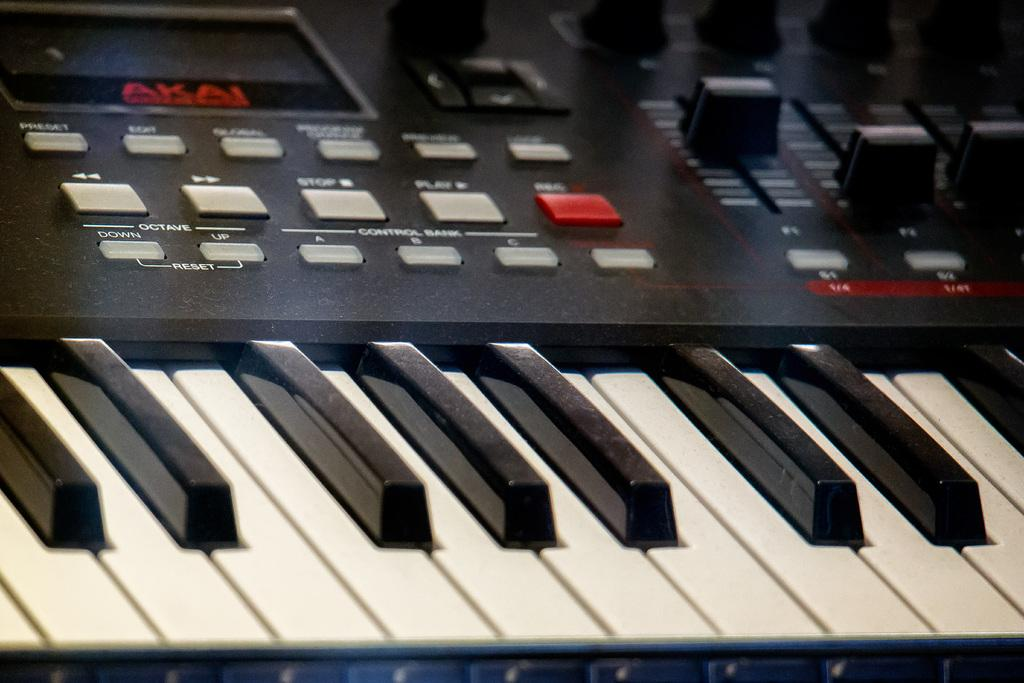<image>
Describe the image concisely. Black and white piano keys for an Akai keyboard. 